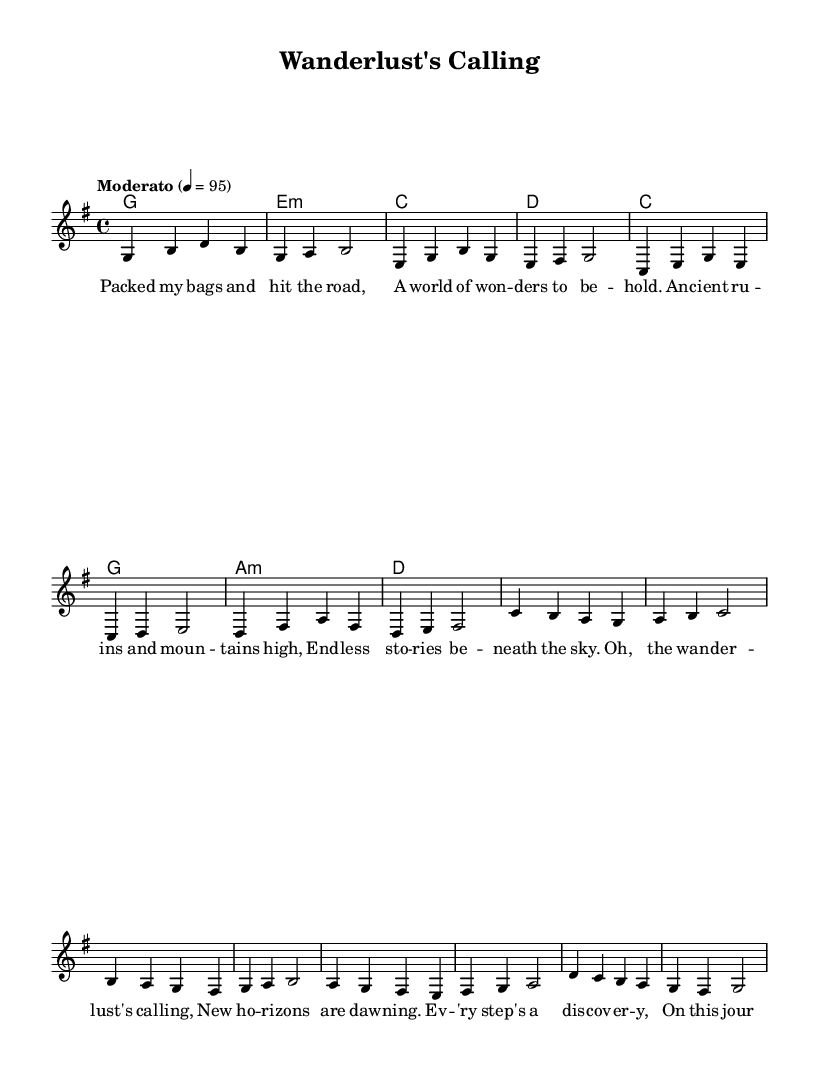What is the key signature of this music? The key signature is G major, which has one sharp (F#). This can be determined by looking at the key signature at the beginning of the sheet music.
Answer: G major What is the time signature of this music? The time signature is 4/4. This is indicated at the beginning of the staff, showing that there are four beats in a measure and each beat is a quarter note.
Answer: 4/4 What is the tempo marking for this piece? The tempo marking is "Moderato," which means moderately fast. It is indicated above the staff along with a metronome marking of 95 beats per minute.
Answer: Moderato How many measures are in the verse section? The verse section consists of 8 measures. By counting the measures in the melody section labeled as "Verse," we see a total of eight distinct measures.
Answer: 8 What chords are used in the chorus? The chords used in the chorus are C, G, A minor, and D. These chords are written in the chord section corresponding to the melody part labeled "Chorus."
Answer: C, G, A minor, D How does the melody in the chorus differ rhythmically from the verse? The melody in the chorus has a more sustained rhythm, where some notes last longer than in the verse. In contrast, the verse includes a mix of shorter and longer notes, creating a more varied rhythmic feel. This difference can be observed by analyzing the note lengths in both sections.
Answer: More sustained What is the main theme explored in the lyrics? The main theme in the lyrics is travel and discovery. The lyrics convey a sense of adventure and exploration, reflecting the excitement of embarking on a journey and the experiences encountered along the way.
Answer: Travel and discovery 